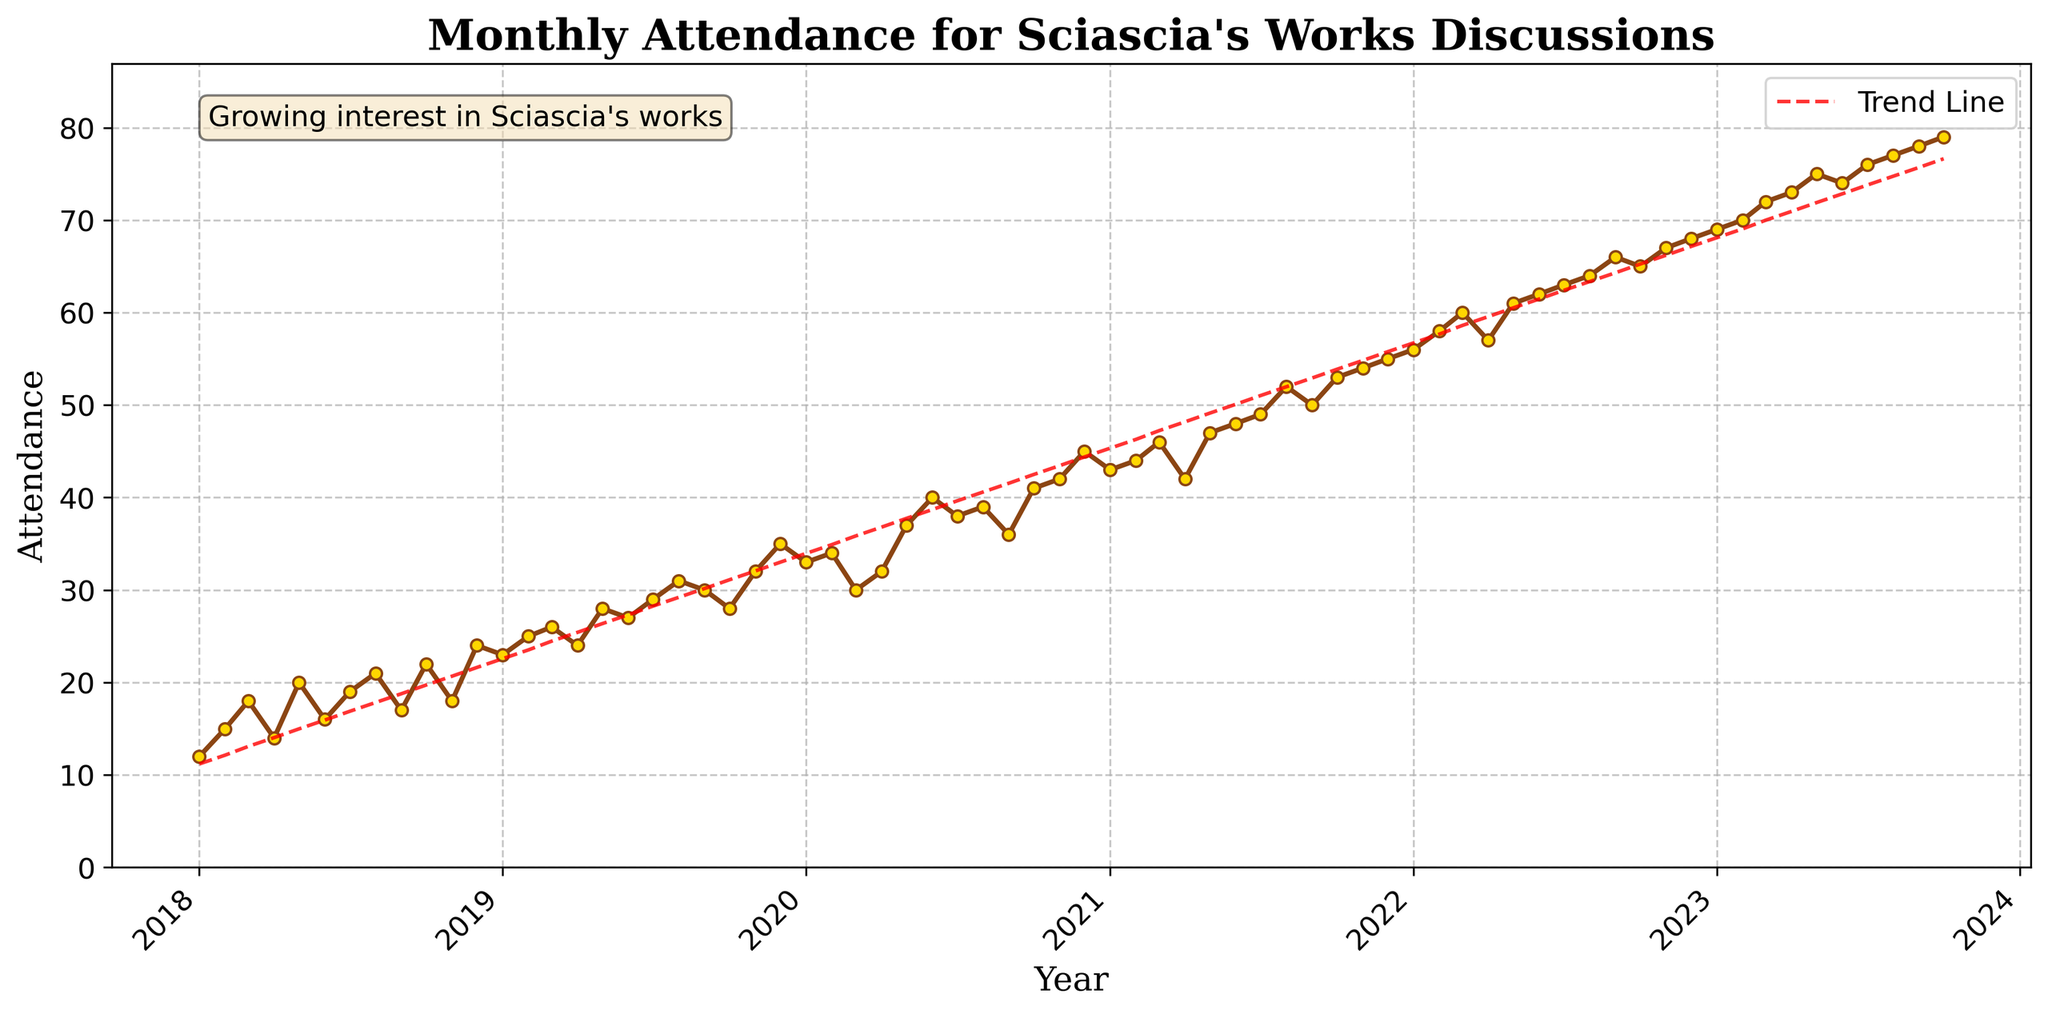How many total data points are plotted in the figure? The figure spans from January 2018 to October 2023. Each month has one data point, so we count the number of months between these two dates. There are 5 full years (60 months) plus 10 additional months in 2023, making a total of 70 data points. Therefore, the figure contains 70 data points.
Answer: 70 By how much did the attendance increase from January 2018 to October 2023? The attendance in January 2018 was 12 and in October 2023, it was 79. To find the increase, subtract the earlier attendance from the later attendance: 79 - 12 = 67. So, attendance increased by 67.
Answer: 67 What month had the highest attendance over the last five years? The highest point on the y-axis where the attendance is marked is in October 2023 with an attendance of 79. This can be seen as the highest point plotted on the time series.
Answer: October 2023 Describe the trend in attendance over the five years. To identify the trend, observe the general direction of the plotted data points and the trend line. The attendance values increase over time, showing a positive trend. This is also reflected in the upward sloping trend line. The text annotation further reinforces the idea of growing interest. Therefore, the trend in attendance is upward.
Answer: Upward What was the attendance in December 2020? Locate the point for December 2020 on the x-axis and follow it upwards to the attendance value. The attendance in December 2020 is marked at 45.
Answer: 45 When did the attendance first exceed 50? Looking at the data points sequentially, the first time attendance exceeds 50 occurs in August 2021, where the attendance reaches 52.
Answer: August 2021 What is the average monthly attendance in 2019? Add the attendance figures for each month in 2019: (23 + 25 + 26 + 24 + 28 + 27 + 29 + 31 + 30 + 28 + 32 + 35) = 338. There are 12 months, so divide the total by 12: 338 / 12 = 28.17. The average monthly attendance in 2019 is approximately 28.17.
Answer: 28.17 In which year did the attendance experience the largest single-year increase? Calculate the difference for each year:
2018 to 2019: 35 - 12 = 23
2019 to 2020: 45 - 35 = 10
2020 to 2021: 55 - 45 = 10
2021 to 2022: 68 - 55 = 13
2022 to 2023 (up to October): 79 - 68 = 11
The largest single-year increase is from 2018 to 2019, with an increase of 23.
Answer: 2018 to 2019 What was the highest attendance recorded in a month in 2022? Check the attendance figures for each month in 2022 to find the maximum: the highest attendance recorded is in December 2022, with 68 attendees.
Answer: December 2022, 68 How many months saw attendance figures greater than 50 over the entire period? Identify months with attendance more than 50: August 2021 to October 2023. Counting these months, there are (12 months starting from August 2021 to August 2022) + (14 months from August 2022 to October 2023) = 15 months total.
Answer: 15 